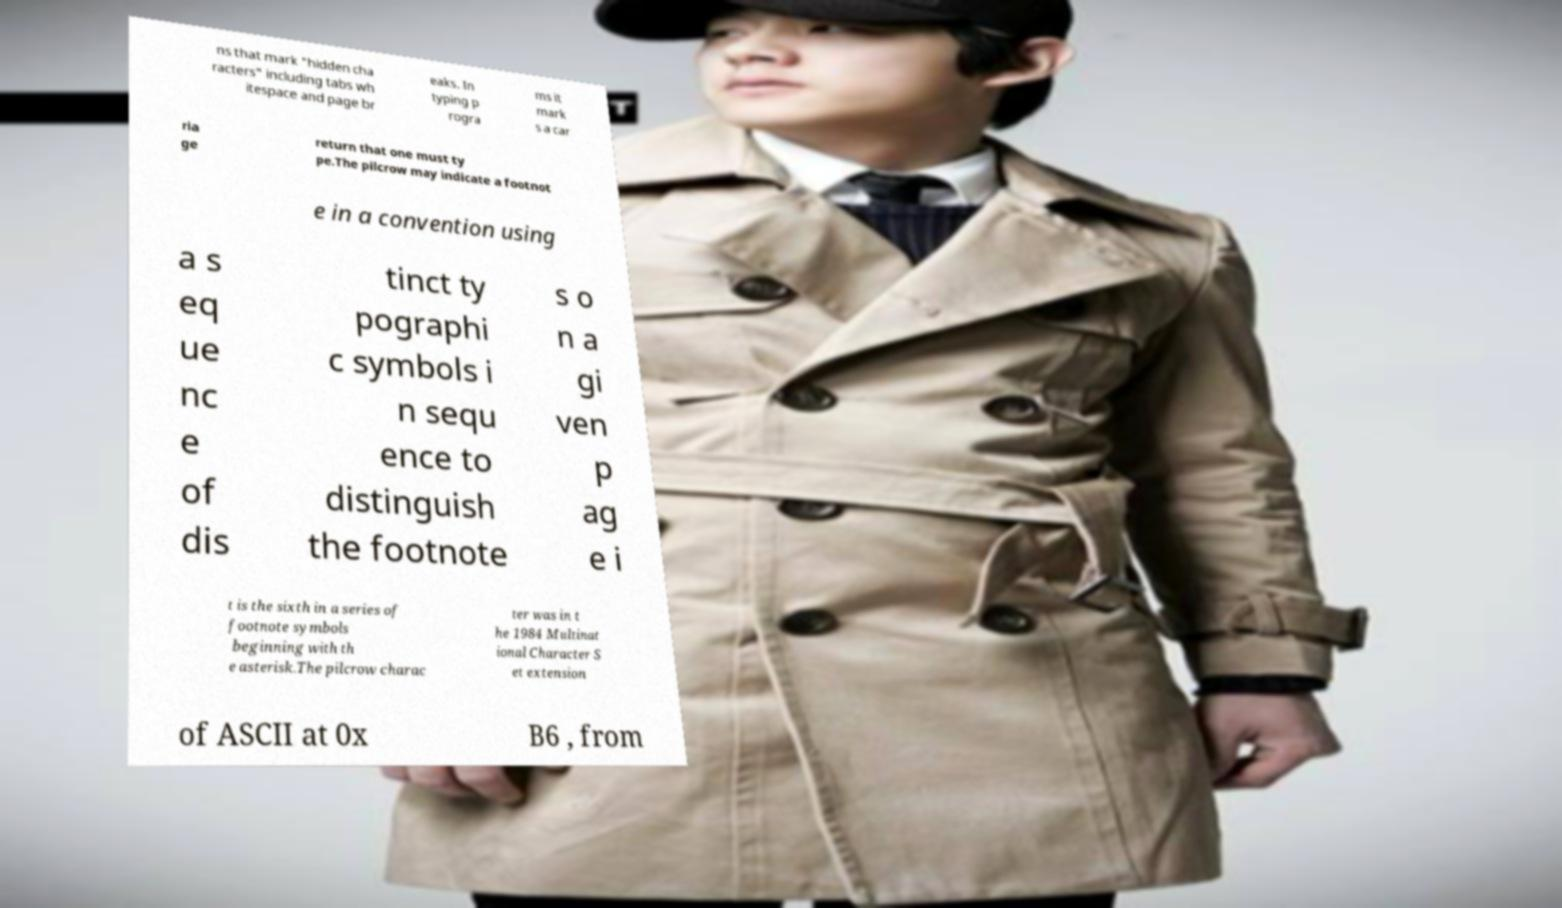Please read and relay the text visible in this image. What does it say? ns that mark "hidden cha racters" including tabs wh itespace and page br eaks. In typing p rogra ms it mark s a car ria ge return that one must ty pe.The pilcrow may indicate a footnot e in a convention using a s eq ue nc e of dis tinct ty pographi c symbols i n sequ ence to distinguish the footnote s o n a gi ven p ag e i t is the sixth in a series of footnote symbols beginning with th e asterisk.The pilcrow charac ter was in t he 1984 Multinat ional Character S et extension of ASCII at 0x B6 , from 